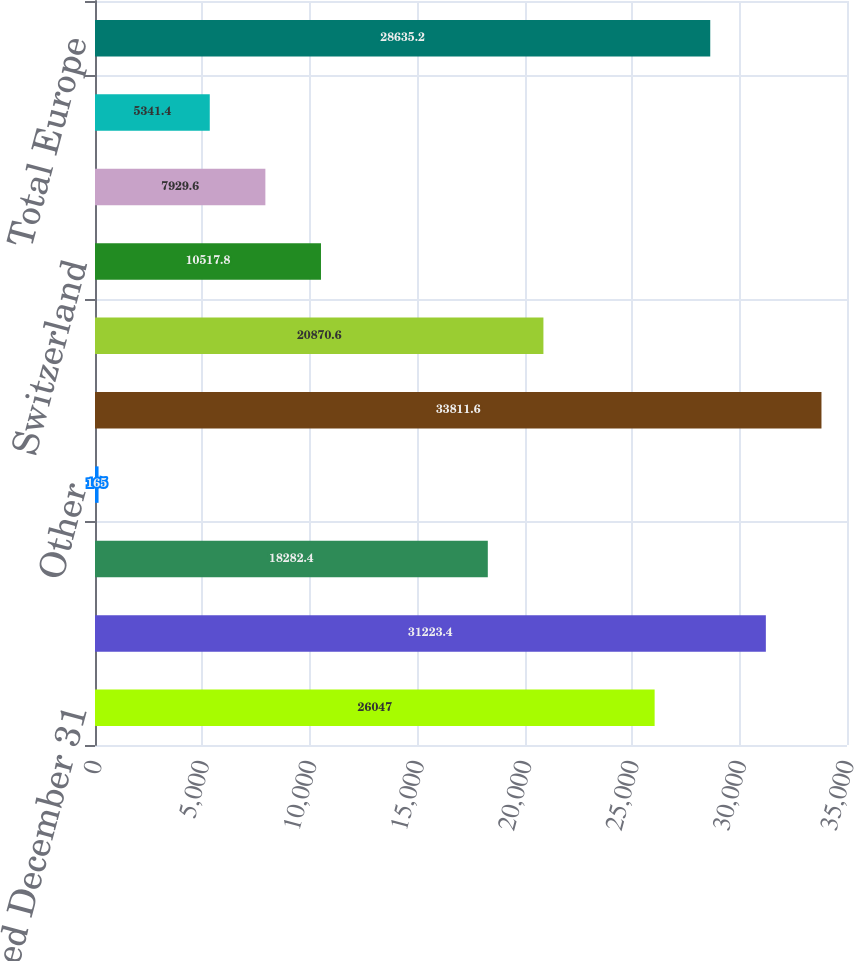Convert chart to OTSL. <chart><loc_0><loc_0><loc_500><loc_500><bar_chart><fcel>Year Ended December 31<fcel>United States<fcel>Canada<fcel>Other<fcel>Total North America<fcel>United Kingdom<fcel>Switzerland<fcel>Russia<fcel>Spain<fcel>Total Europe<nl><fcel>26047<fcel>31223.4<fcel>18282.4<fcel>165<fcel>33811.6<fcel>20870.6<fcel>10517.8<fcel>7929.6<fcel>5341.4<fcel>28635.2<nl></chart> 